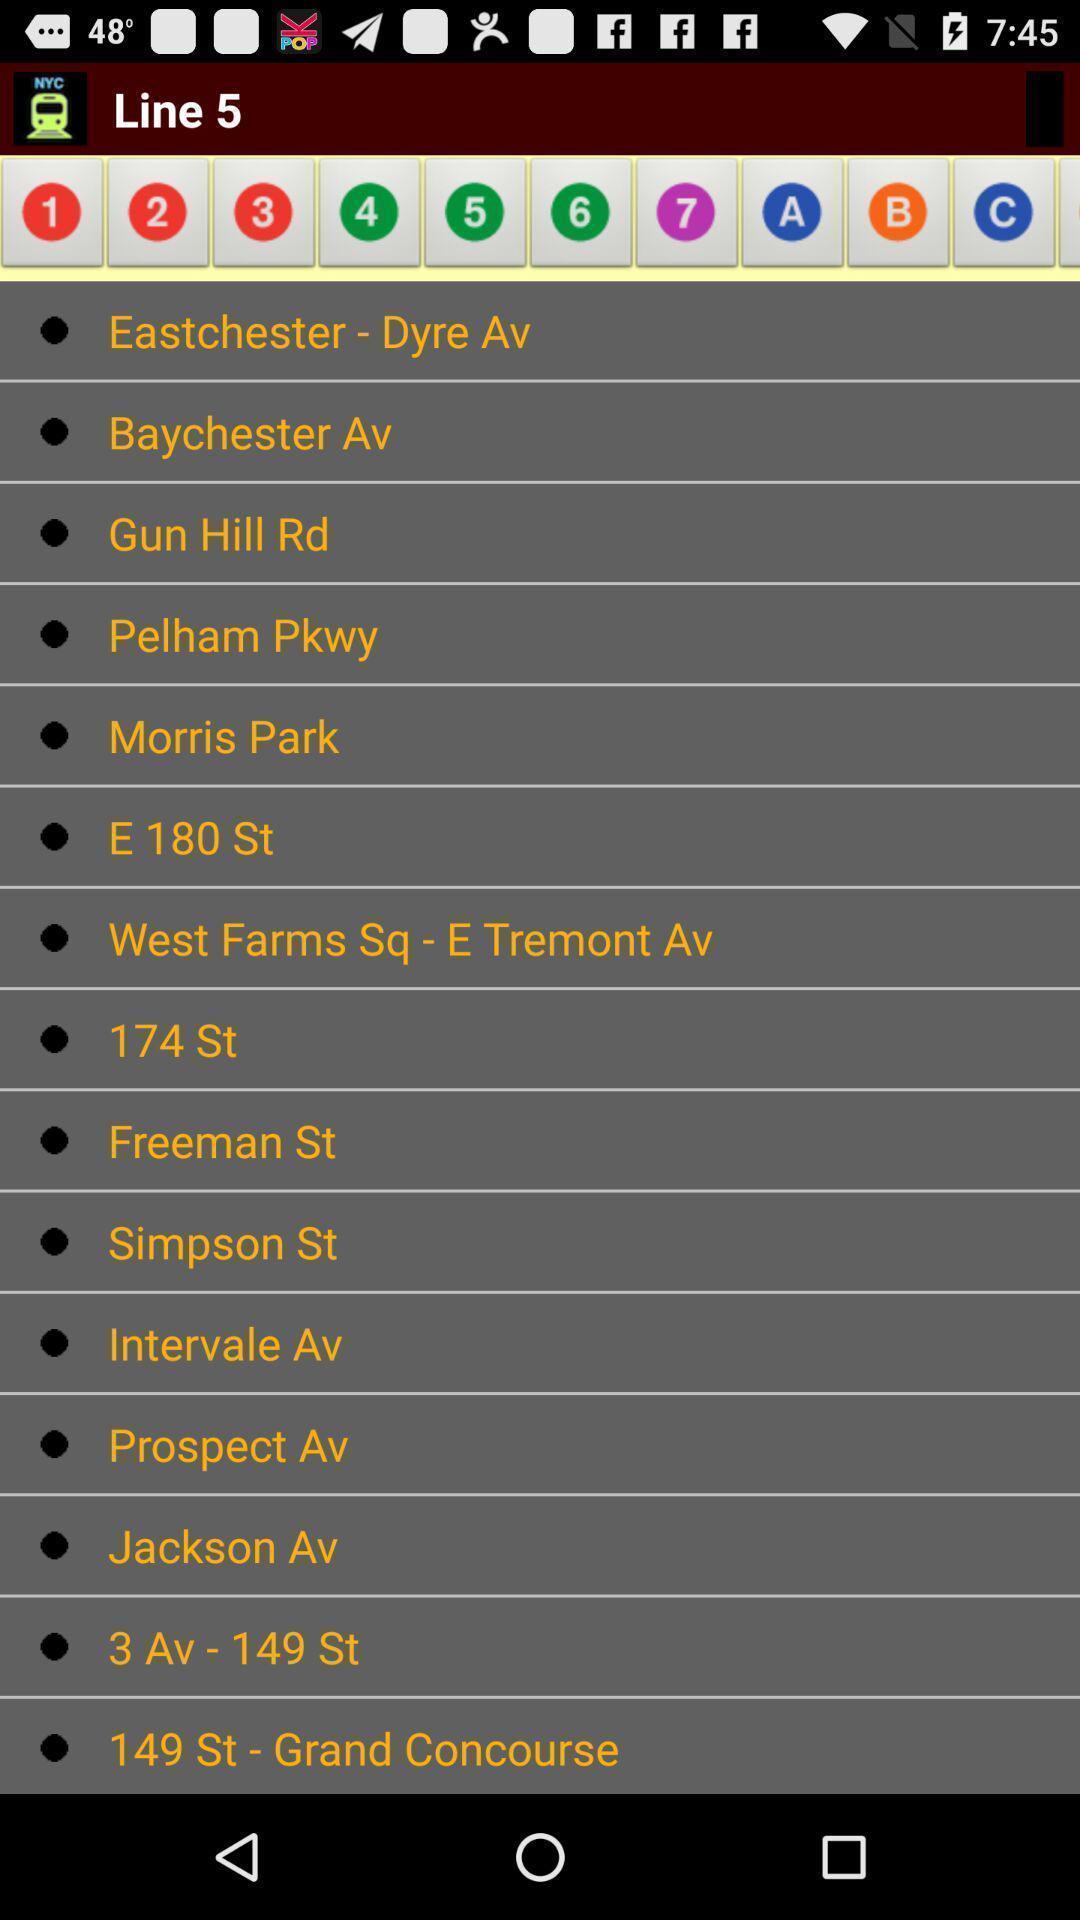Give me a summary of this screen capture. Screen showing page of an railway application. 